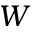<formula> <loc_0><loc_0><loc_500><loc_500>W</formula> 